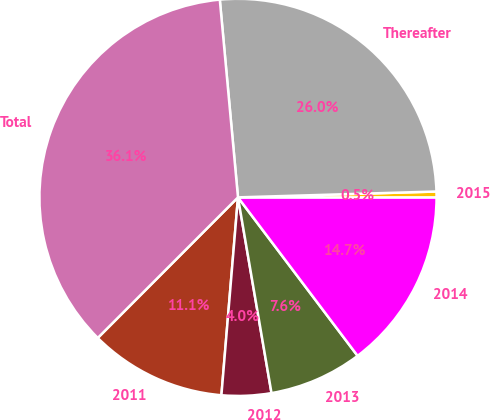<chart> <loc_0><loc_0><loc_500><loc_500><pie_chart><fcel>2011<fcel>2012<fcel>2013<fcel>2014<fcel>2015<fcel>Thereafter<fcel>Total<nl><fcel>11.15%<fcel>4.03%<fcel>7.59%<fcel>14.71%<fcel>0.47%<fcel>25.99%<fcel>36.06%<nl></chart> 